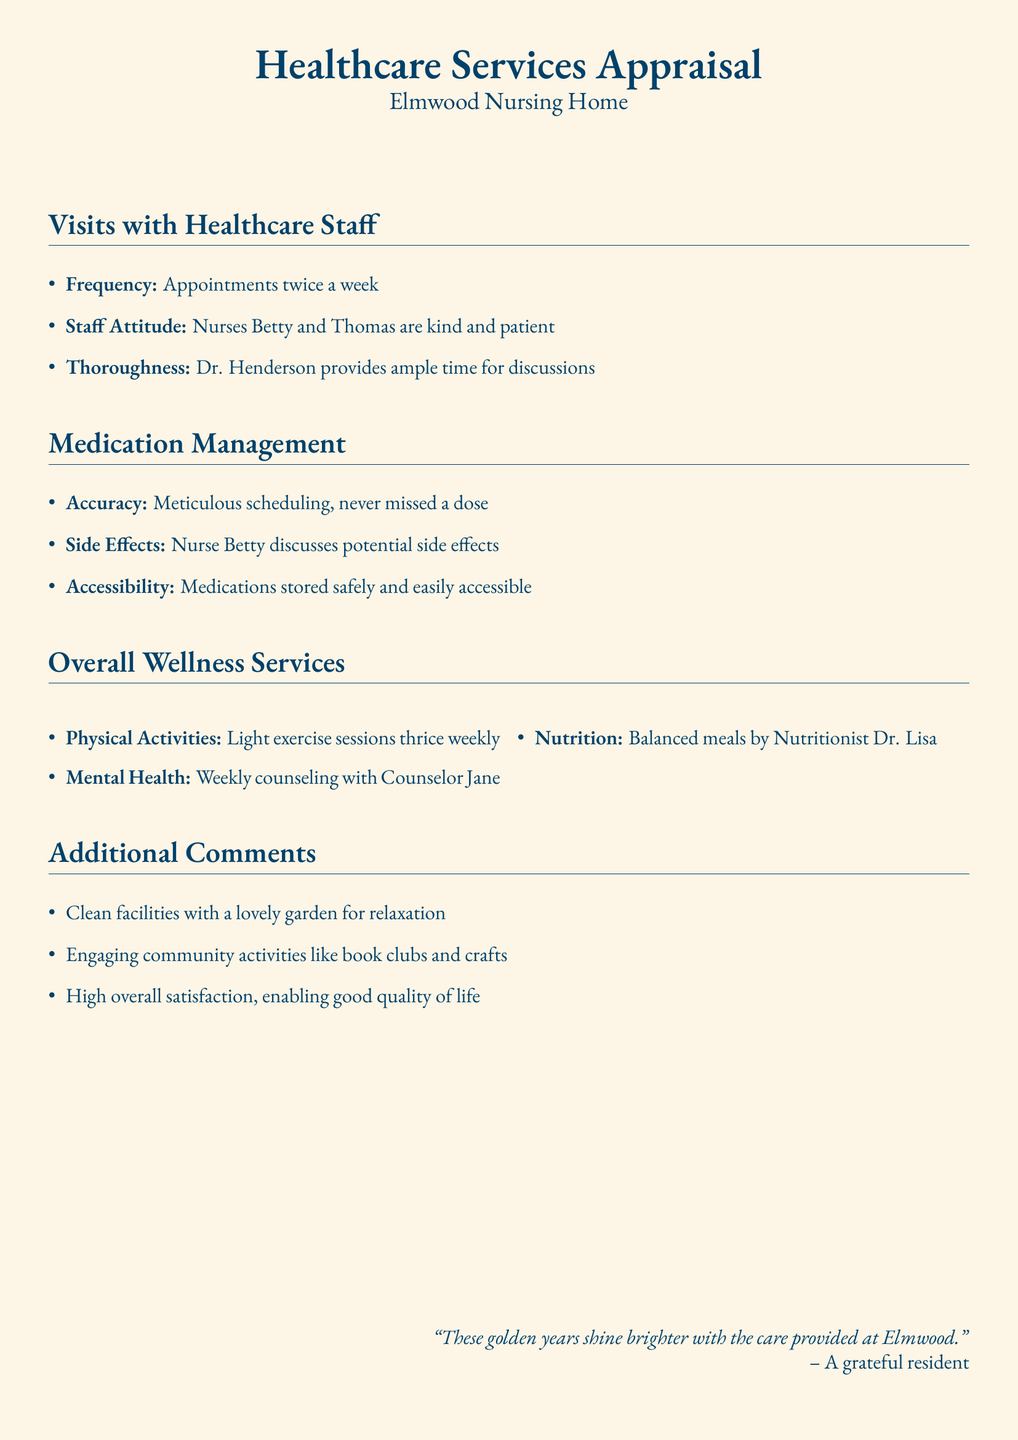What is the frequency of appointments? The frequency of appointments is specified in the document under "Visits with Healthcare Staff," which states "twice a week."
Answer: twice a week Who provides weekly counseling? The document lists the personnel involved in wellness services, indicating that weekly counseling is provided by "Counselor Jane."
Answer: Counselor Jane How often are light exercise sessions held? The information under "Overall Wellness Services" states that light exercise sessions occur "thrice weekly."
Answer: thrice weekly What is mentioned about Nurse Betty's role? The document highlights Nurse Betty's function in medication management, specifying that she "discusses potential side effects."
Answer: discusses potential side effects How would you describe the facilities? The document includes a comment about the cleanliness of the facilities, stating "clean facilities with a lovely garden for relaxation."
Answer: clean facilities Which healthcare staff are mentioned for their kind and patient attitude? The "Staff Attitude" section names the healthcare staff noted for their demeanor, which includes "Nurses Betty and Thomas."
Answer: Nurses Betty and Thomas What type of meals are provided? The nutrition services section mentions that meals are "balanced," as provided by "Nutritionist Dr. Lisa."
Answer: balanced meals What additional community activities are highlighted? The document references "engaging community activities like book clubs and crafts" as part of the overall services.
Answer: book clubs and crafts 